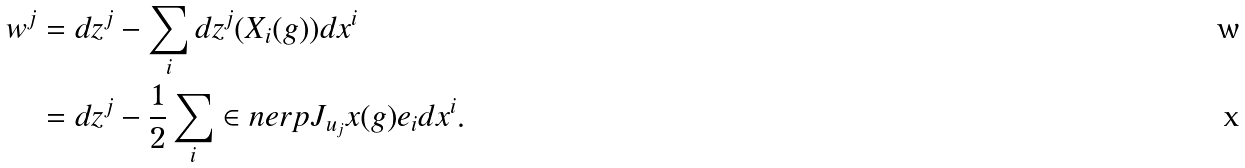<formula> <loc_0><loc_0><loc_500><loc_500>w ^ { j } & = d z ^ { j } - \sum _ { i } d z ^ { j } ( X _ { i } ( g ) ) d x ^ { i } \\ & = d z ^ { j } - \frac { 1 } { 2 } \sum _ { i } \in n e r p { J _ { u _ { j } } x ( g ) } { e _ { i } } d x ^ { i } .</formula> 